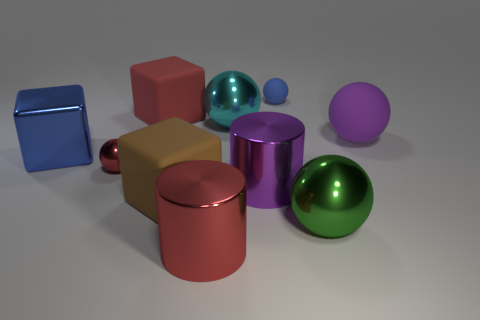Subtract all purple cylinders. Subtract all green blocks. How many cylinders are left? 1 Subtract all red cylinders. How many purple spheres are left? 1 Add 2 small greens. How many big cyans exist? 0 Subtract all blocks. Subtract all red cubes. How many objects are left? 6 Add 4 big brown blocks. How many big brown blocks are left? 5 Add 2 large brown cubes. How many large brown cubes exist? 3 Subtract all red spheres. How many spheres are left? 4 Subtract all metal spheres. How many spheres are left? 2 Subtract 0 yellow cylinders. How many objects are left? 10 Subtract all blocks. How many objects are left? 7 